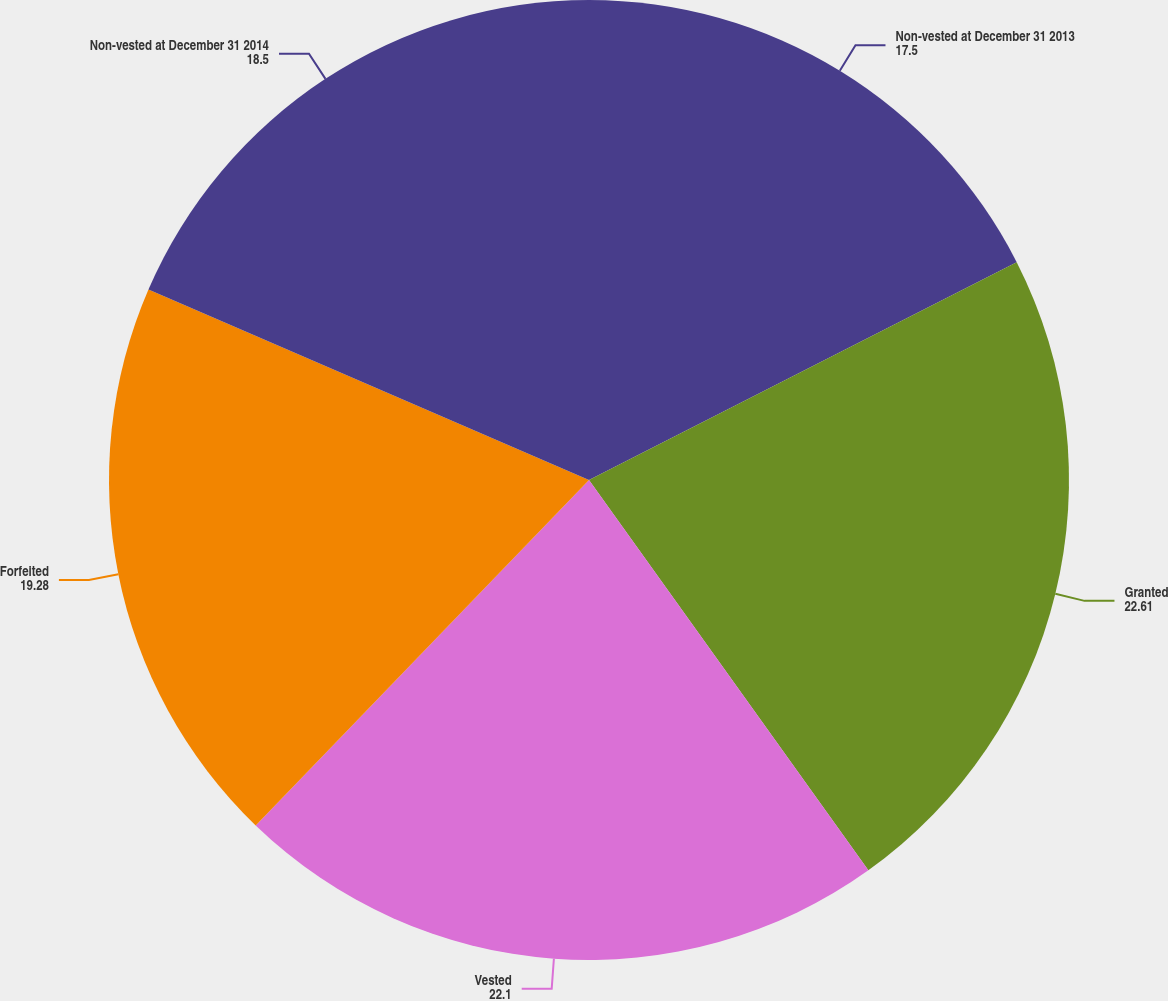Convert chart to OTSL. <chart><loc_0><loc_0><loc_500><loc_500><pie_chart><fcel>Non-vested at December 31 2013<fcel>Granted<fcel>Vested<fcel>Forfeited<fcel>Non-vested at December 31 2014<nl><fcel>17.5%<fcel>22.61%<fcel>22.1%<fcel>19.28%<fcel>18.5%<nl></chart> 